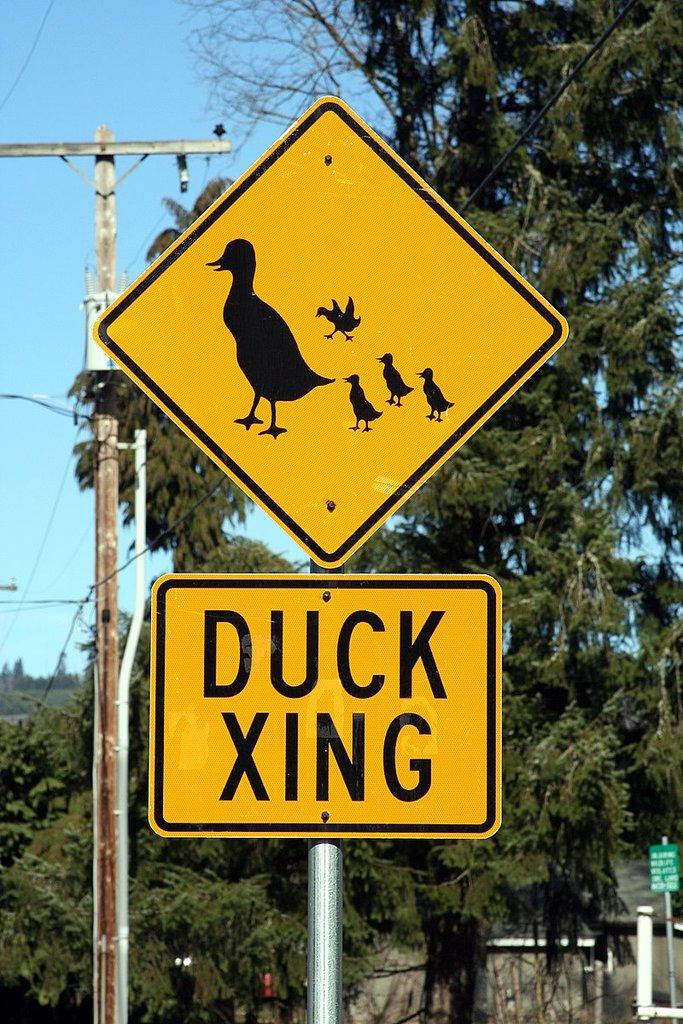What is the main object in the center of the image? There is a sign board in the center of the image. What can be seen in the background of the image? There is a pole and trees in the background of the image. What is visible above the trees and pole in the image? The sky is visible in the background of the image. Can you hear the sound of the lake in the image? There is no lake present in the image, so it is not possible to hear the sound of a lake. 